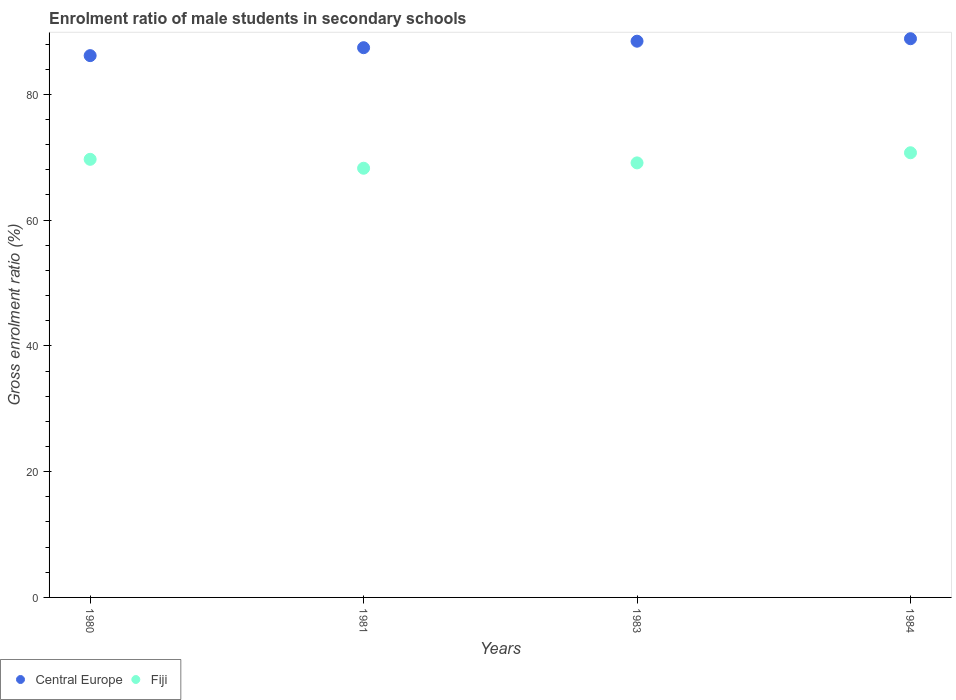What is the enrolment ratio of male students in secondary schools in Fiji in 1980?
Your response must be concise. 69.67. Across all years, what is the maximum enrolment ratio of male students in secondary schools in Central Europe?
Your response must be concise. 88.85. Across all years, what is the minimum enrolment ratio of male students in secondary schools in Central Europe?
Make the answer very short. 86.16. In which year was the enrolment ratio of male students in secondary schools in Fiji maximum?
Offer a very short reply. 1984. In which year was the enrolment ratio of male students in secondary schools in Central Europe minimum?
Offer a very short reply. 1980. What is the total enrolment ratio of male students in secondary schools in Central Europe in the graph?
Provide a succinct answer. 350.88. What is the difference between the enrolment ratio of male students in secondary schools in Fiji in 1980 and that in 1984?
Give a very brief answer. -1.04. What is the difference between the enrolment ratio of male students in secondary schools in Central Europe in 1983 and the enrolment ratio of male students in secondary schools in Fiji in 1980?
Make the answer very short. 18.78. What is the average enrolment ratio of male students in secondary schools in Central Europe per year?
Provide a succinct answer. 87.72. In the year 1980, what is the difference between the enrolment ratio of male students in secondary schools in Fiji and enrolment ratio of male students in secondary schools in Central Europe?
Ensure brevity in your answer.  -16.49. In how many years, is the enrolment ratio of male students in secondary schools in Central Europe greater than 76 %?
Provide a short and direct response. 4. What is the ratio of the enrolment ratio of male students in secondary schools in Fiji in 1980 to that in 1983?
Your response must be concise. 1.01. Is the difference between the enrolment ratio of male students in secondary schools in Fiji in 1981 and 1983 greater than the difference between the enrolment ratio of male students in secondary schools in Central Europe in 1981 and 1983?
Your answer should be compact. Yes. What is the difference between the highest and the second highest enrolment ratio of male students in secondary schools in Fiji?
Your response must be concise. 1.04. What is the difference between the highest and the lowest enrolment ratio of male students in secondary schools in Fiji?
Your answer should be compact. 2.46. In how many years, is the enrolment ratio of male students in secondary schools in Fiji greater than the average enrolment ratio of male students in secondary schools in Fiji taken over all years?
Provide a succinct answer. 2. Is the sum of the enrolment ratio of male students in secondary schools in Central Europe in 1981 and 1983 greater than the maximum enrolment ratio of male students in secondary schools in Fiji across all years?
Make the answer very short. Yes. Does the enrolment ratio of male students in secondary schools in Central Europe monotonically increase over the years?
Keep it short and to the point. Yes. Is the enrolment ratio of male students in secondary schools in Central Europe strictly greater than the enrolment ratio of male students in secondary schools in Fiji over the years?
Give a very brief answer. Yes. What is the difference between two consecutive major ticks on the Y-axis?
Give a very brief answer. 20. How many legend labels are there?
Offer a terse response. 2. How are the legend labels stacked?
Ensure brevity in your answer.  Horizontal. What is the title of the graph?
Your response must be concise. Enrolment ratio of male students in secondary schools. What is the label or title of the X-axis?
Keep it short and to the point. Years. What is the label or title of the Y-axis?
Ensure brevity in your answer.  Gross enrolment ratio (%). What is the Gross enrolment ratio (%) of Central Europe in 1980?
Make the answer very short. 86.16. What is the Gross enrolment ratio (%) in Fiji in 1980?
Keep it short and to the point. 69.67. What is the Gross enrolment ratio (%) in Central Europe in 1981?
Provide a short and direct response. 87.42. What is the Gross enrolment ratio (%) in Fiji in 1981?
Make the answer very short. 68.25. What is the Gross enrolment ratio (%) in Central Europe in 1983?
Keep it short and to the point. 88.45. What is the Gross enrolment ratio (%) in Fiji in 1983?
Keep it short and to the point. 69.1. What is the Gross enrolment ratio (%) in Central Europe in 1984?
Your response must be concise. 88.85. What is the Gross enrolment ratio (%) of Fiji in 1984?
Make the answer very short. 70.71. Across all years, what is the maximum Gross enrolment ratio (%) of Central Europe?
Keep it short and to the point. 88.85. Across all years, what is the maximum Gross enrolment ratio (%) in Fiji?
Provide a succinct answer. 70.71. Across all years, what is the minimum Gross enrolment ratio (%) of Central Europe?
Keep it short and to the point. 86.16. Across all years, what is the minimum Gross enrolment ratio (%) of Fiji?
Your answer should be very brief. 68.25. What is the total Gross enrolment ratio (%) in Central Europe in the graph?
Offer a terse response. 350.88. What is the total Gross enrolment ratio (%) of Fiji in the graph?
Keep it short and to the point. 277.74. What is the difference between the Gross enrolment ratio (%) in Central Europe in 1980 and that in 1981?
Offer a very short reply. -1.26. What is the difference between the Gross enrolment ratio (%) in Fiji in 1980 and that in 1981?
Offer a very short reply. 1.42. What is the difference between the Gross enrolment ratio (%) of Central Europe in 1980 and that in 1983?
Offer a very short reply. -2.29. What is the difference between the Gross enrolment ratio (%) of Fiji in 1980 and that in 1983?
Your response must be concise. 0.57. What is the difference between the Gross enrolment ratio (%) in Central Europe in 1980 and that in 1984?
Make the answer very short. -2.69. What is the difference between the Gross enrolment ratio (%) in Fiji in 1980 and that in 1984?
Ensure brevity in your answer.  -1.04. What is the difference between the Gross enrolment ratio (%) in Central Europe in 1981 and that in 1983?
Offer a terse response. -1.03. What is the difference between the Gross enrolment ratio (%) of Fiji in 1981 and that in 1983?
Give a very brief answer. -0.85. What is the difference between the Gross enrolment ratio (%) in Central Europe in 1981 and that in 1984?
Your answer should be compact. -1.43. What is the difference between the Gross enrolment ratio (%) in Fiji in 1981 and that in 1984?
Keep it short and to the point. -2.46. What is the difference between the Gross enrolment ratio (%) in Central Europe in 1983 and that in 1984?
Your answer should be very brief. -0.39. What is the difference between the Gross enrolment ratio (%) in Fiji in 1983 and that in 1984?
Ensure brevity in your answer.  -1.61. What is the difference between the Gross enrolment ratio (%) in Central Europe in 1980 and the Gross enrolment ratio (%) in Fiji in 1981?
Ensure brevity in your answer.  17.91. What is the difference between the Gross enrolment ratio (%) in Central Europe in 1980 and the Gross enrolment ratio (%) in Fiji in 1983?
Your answer should be very brief. 17.06. What is the difference between the Gross enrolment ratio (%) in Central Europe in 1980 and the Gross enrolment ratio (%) in Fiji in 1984?
Make the answer very short. 15.45. What is the difference between the Gross enrolment ratio (%) in Central Europe in 1981 and the Gross enrolment ratio (%) in Fiji in 1983?
Provide a short and direct response. 18.32. What is the difference between the Gross enrolment ratio (%) of Central Europe in 1981 and the Gross enrolment ratio (%) of Fiji in 1984?
Offer a very short reply. 16.71. What is the difference between the Gross enrolment ratio (%) of Central Europe in 1983 and the Gross enrolment ratio (%) of Fiji in 1984?
Your answer should be compact. 17.74. What is the average Gross enrolment ratio (%) in Central Europe per year?
Your answer should be compact. 87.72. What is the average Gross enrolment ratio (%) of Fiji per year?
Provide a short and direct response. 69.43. In the year 1980, what is the difference between the Gross enrolment ratio (%) of Central Europe and Gross enrolment ratio (%) of Fiji?
Make the answer very short. 16.49. In the year 1981, what is the difference between the Gross enrolment ratio (%) of Central Europe and Gross enrolment ratio (%) of Fiji?
Your answer should be very brief. 19.17. In the year 1983, what is the difference between the Gross enrolment ratio (%) in Central Europe and Gross enrolment ratio (%) in Fiji?
Your answer should be compact. 19.35. In the year 1984, what is the difference between the Gross enrolment ratio (%) of Central Europe and Gross enrolment ratio (%) of Fiji?
Make the answer very short. 18.13. What is the ratio of the Gross enrolment ratio (%) of Central Europe in 1980 to that in 1981?
Provide a short and direct response. 0.99. What is the ratio of the Gross enrolment ratio (%) in Fiji in 1980 to that in 1981?
Your response must be concise. 1.02. What is the ratio of the Gross enrolment ratio (%) of Central Europe in 1980 to that in 1983?
Provide a succinct answer. 0.97. What is the ratio of the Gross enrolment ratio (%) of Fiji in 1980 to that in 1983?
Ensure brevity in your answer.  1.01. What is the ratio of the Gross enrolment ratio (%) in Central Europe in 1980 to that in 1984?
Offer a very short reply. 0.97. What is the ratio of the Gross enrolment ratio (%) in Central Europe in 1981 to that in 1983?
Provide a short and direct response. 0.99. What is the ratio of the Gross enrolment ratio (%) in Central Europe in 1981 to that in 1984?
Make the answer very short. 0.98. What is the ratio of the Gross enrolment ratio (%) in Fiji in 1981 to that in 1984?
Offer a very short reply. 0.97. What is the ratio of the Gross enrolment ratio (%) in Fiji in 1983 to that in 1984?
Ensure brevity in your answer.  0.98. What is the difference between the highest and the second highest Gross enrolment ratio (%) of Central Europe?
Keep it short and to the point. 0.39. What is the difference between the highest and the second highest Gross enrolment ratio (%) in Fiji?
Your answer should be very brief. 1.04. What is the difference between the highest and the lowest Gross enrolment ratio (%) in Central Europe?
Your answer should be compact. 2.69. What is the difference between the highest and the lowest Gross enrolment ratio (%) in Fiji?
Give a very brief answer. 2.46. 